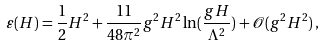Convert formula to latex. <formula><loc_0><loc_0><loc_500><loc_500>\varepsilon ( H ) = \frac { 1 } { 2 } H ^ { 2 } + \frac { 1 1 } { 4 8 \pi ^ { 2 } } g ^ { 2 } H ^ { 2 } \ln ( \frac { g H } { \Lambda ^ { 2 } } ) + { \mathcal { O } } ( g ^ { 2 } H ^ { 2 } ) \, ,</formula> 